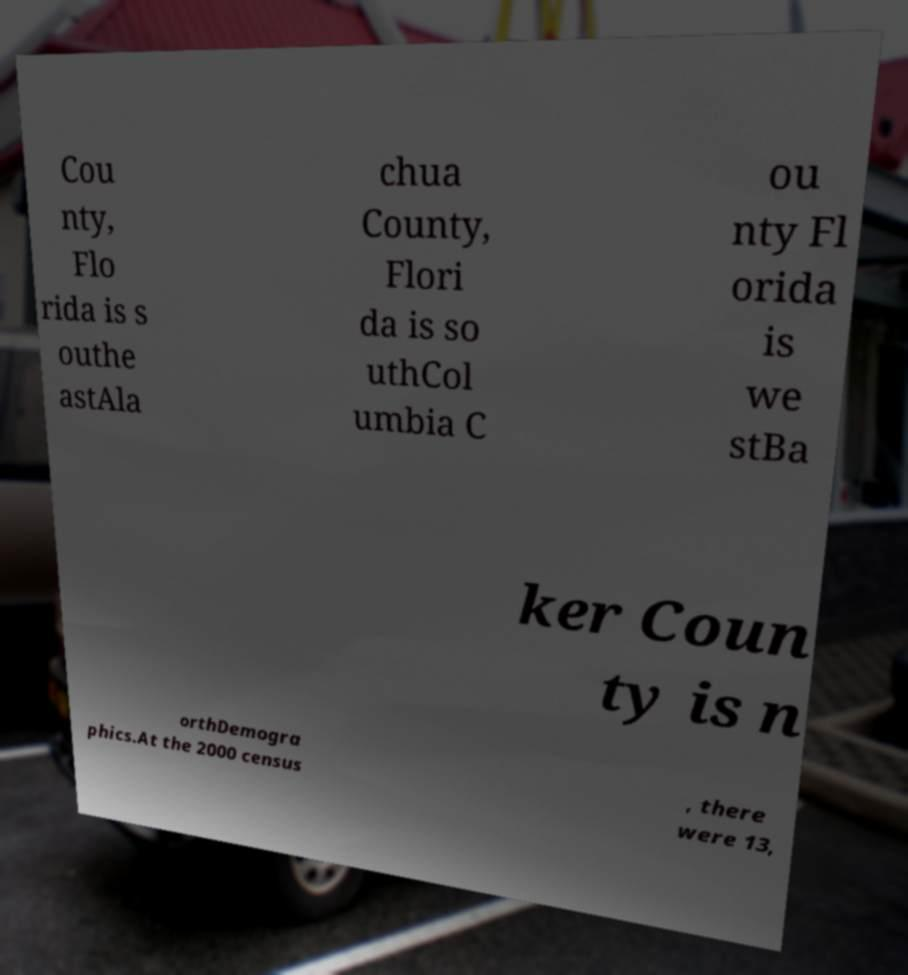Could you assist in decoding the text presented in this image and type it out clearly? Cou nty, Flo rida is s outhe astAla chua County, Flori da is so uthCol umbia C ou nty Fl orida is we stBa ker Coun ty is n orthDemogra phics.At the 2000 census , there were 13, 